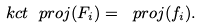Convert formula to latex. <formula><loc_0><loc_0><loc_500><loc_500>\ k c t \ p r o j ( F _ { i } ) = \ p r o j ( f _ { i } ) .</formula> 